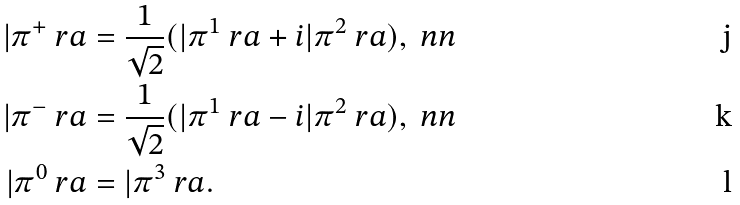Convert formula to latex. <formula><loc_0><loc_0><loc_500><loc_500>| \pi ^ { + } \ r a & = \frac { 1 } { \sqrt { 2 } } ( | \pi ^ { 1 } \ r a + i | \pi ^ { 2 } \ r a ) , \ n n \\ | \pi ^ { - } \ r a & = \frac { 1 } { \sqrt { 2 } } ( | \pi ^ { 1 } \ r a - i | \pi ^ { 2 } \ r a ) , \ n n \\ | \pi ^ { 0 } \ r a & = | \pi ^ { 3 } \ r a .</formula> 